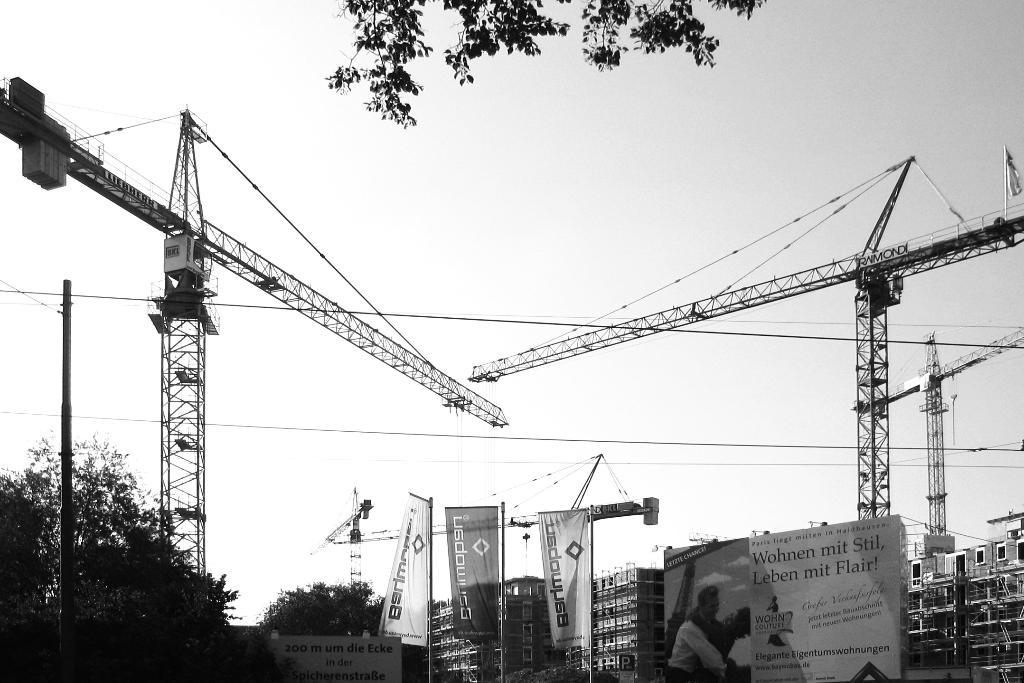What type of structures can be seen in the image? There are buildings in the image. What other elements are present in the image besides buildings? There are trees, banners with text, poles, and cranes in the image. What can be seen in the background of the image? The sky is visible in the background of the image. What type of throat lozenges are being advertised on the banners in the image? There are no throat lozenges or advertisements mentioned in the image; the banners contain text, but the content is not specified. 